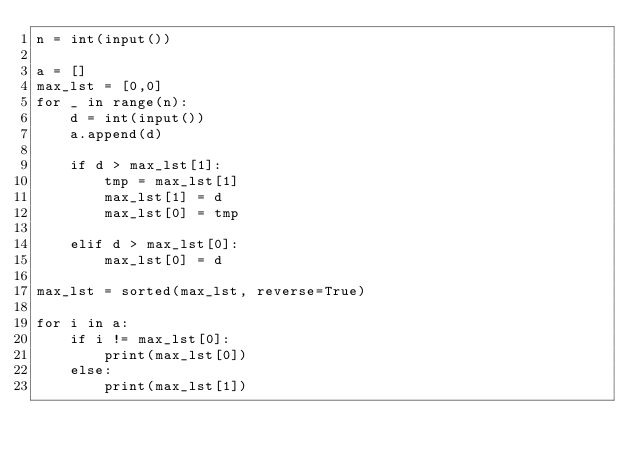<code> <loc_0><loc_0><loc_500><loc_500><_Python_>n = int(input())

a = []
max_lst = [0,0]
for _ in range(n):
    d = int(input())
    a.append(d)

    if d > max_lst[1]:
        tmp = max_lst[1]
        max_lst[1] = d 
        max_lst[0] = tmp
    
    elif d > max_lst[0]:
        max_lst[0] = d
        
max_lst = sorted(max_lst, reverse=True)

for i in a:
    if i != max_lst[0]:
        print(max_lst[0])
    else:
        print(max_lst[1])




</code> 